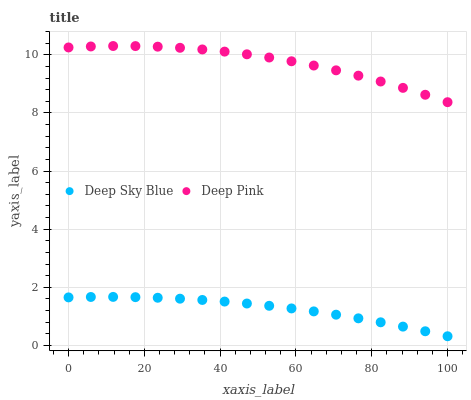Does Deep Sky Blue have the minimum area under the curve?
Answer yes or no. Yes. Does Deep Pink have the maximum area under the curve?
Answer yes or no. Yes. Does Deep Sky Blue have the maximum area under the curve?
Answer yes or no. No. Is Deep Sky Blue the smoothest?
Answer yes or no. Yes. Is Deep Pink the roughest?
Answer yes or no. Yes. Is Deep Sky Blue the roughest?
Answer yes or no. No. Does Deep Sky Blue have the lowest value?
Answer yes or no. Yes. Does Deep Pink have the highest value?
Answer yes or no. Yes. Does Deep Sky Blue have the highest value?
Answer yes or no. No. Is Deep Sky Blue less than Deep Pink?
Answer yes or no. Yes. Is Deep Pink greater than Deep Sky Blue?
Answer yes or no. Yes. Does Deep Sky Blue intersect Deep Pink?
Answer yes or no. No. 